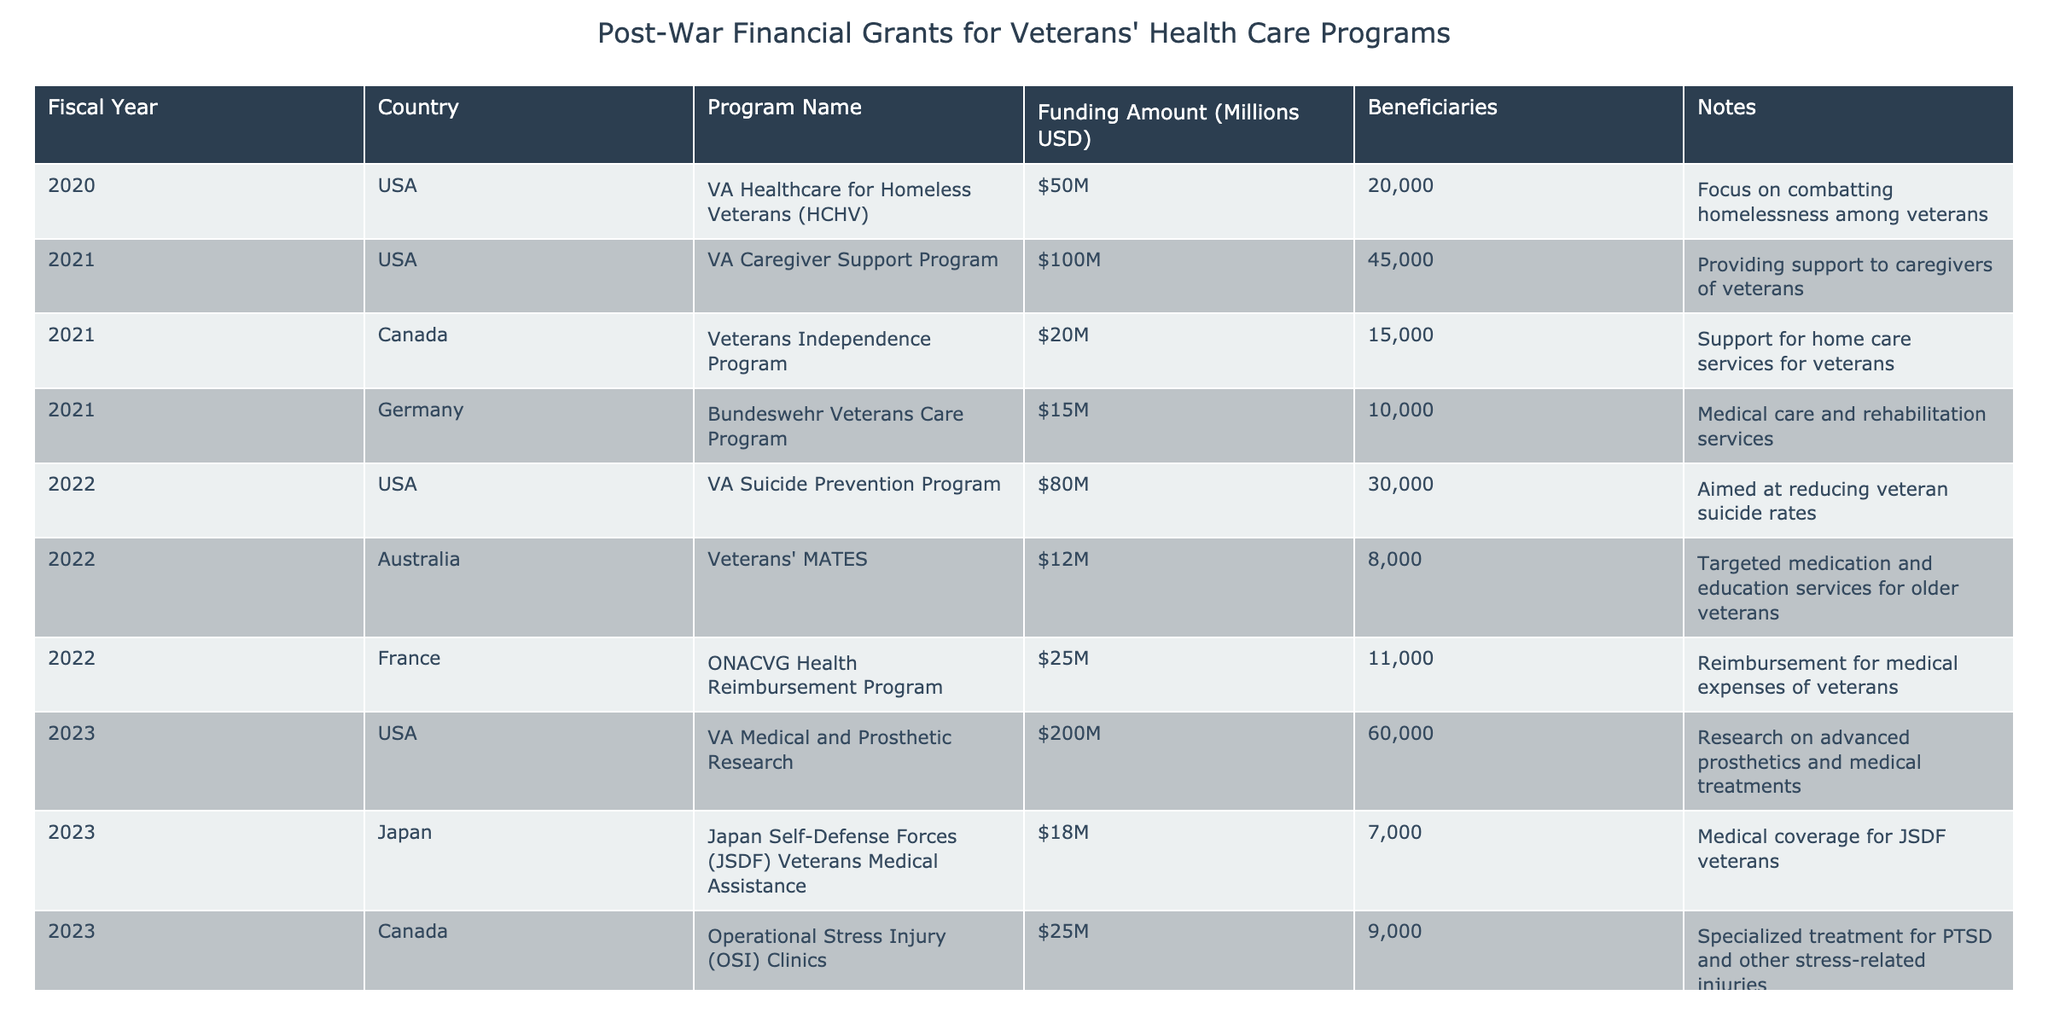What program received the highest funding amount in 2023? The program that received the highest funding amount in 2023 can be found by looking at the "Funding Amount (Millions USD)" column for that year. The VA Medical and Prosthetic Research received $200 million, which is the highest among the listed programs for 2023.
Answer: VA Medical and Prosthetic Research Which country has the most programs listed in this table? By scanning through the "Country" column, it becomes evident that the USA has four programs listed, while other countries like Canada, Germany, Australia, and France have only one or two. Therefore, the USA has the most programs in the table.
Answer: USA What was the total funding amount for programs in 2022? To find the total funding amount for programs in 2022, we sum the funding amounts for each program listed for that year: 80 million + 12 million + 25 million = 117 million. Thus, the total funding for programs in 2022 is $117 million.
Answer: 117 million Did Canada provide funding for PTSD treatment in 2023? Yes, Canada did provide funding for PTSD treatment in 2023 through the Operational Stress Injury (OSI) Clinics program, which focuses on specialized treatment for PTSD and other stress-related injuries according to the notes.
Answer: Yes How much funding did Australia receive compared to Germany in 2021? In 2021, Australia's Veterans' MATES program received $12 million, while Germany's Bundeswehr Veterans Care Program received $15 million. Therefore, comparing the two shows that Germany received $3 million more than Australia in that year.
Answer: $3 million more for Germany What is the average funding amount for all programs listed in 2021? To calculate the average funding amount for programs in 2021, we first need to sum the funding amounts: $100 million (USA) + $20 million (Canada) + $15 million (Germany) = $135 million. Since there are three programs, we divide by 3, which gives an average of $45 million.
Answer: 45 million Is the funding for the VA Healthcare for Homeless Veterans related to vocational training? No, the funding for the VA Healthcare for Homeless Veterans program is focused on combatting homelessness among veterans, not vocational training.
Answer: No Which program had the least funding amount in 2022, and what was it? The program with the least funding amount in 2022 can be determined by examining the funding levels for that year. The Veterans' MATES program in Australia received $12 million, making it the program with the least funding amount for 2022.
Answer: Veterans' MATES, $12 million 